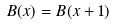Convert formula to latex. <formula><loc_0><loc_0><loc_500><loc_500>B ( x ) = B ( x + 1 )</formula> 